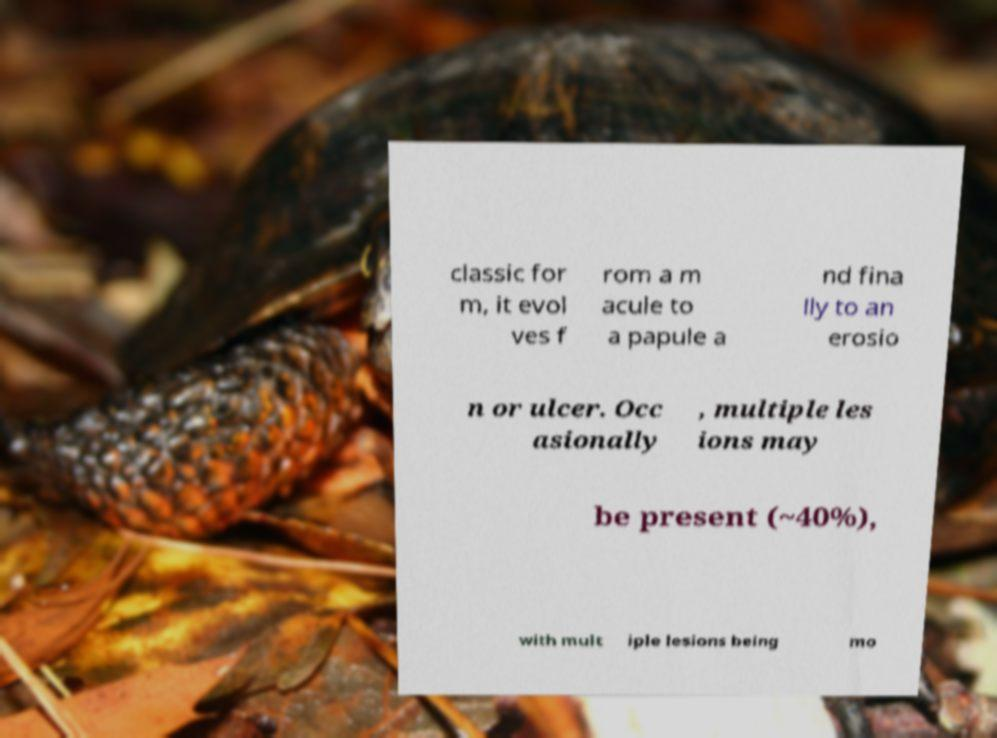Please read and relay the text visible in this image. What does it say? classic for m, it evol ves f rom a m acule to a papule a nd fina lly to an erosio n or ulcer. Occ asionally , multiple les ions may be present (~40%), with mult iple lesions being mo 